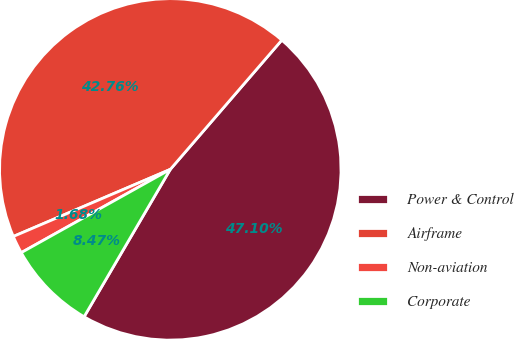<chart> <loc_0><loc_0><loc_500><loc_500><pie_chart><fcel>Power & Control<fcel>Airframe<fcel>Non-aviation<fcel>Corporate<nl><fcel>47.1%<fcel>42.76%<fcel>1.68%<fcel>8.47%<nl></chart> 